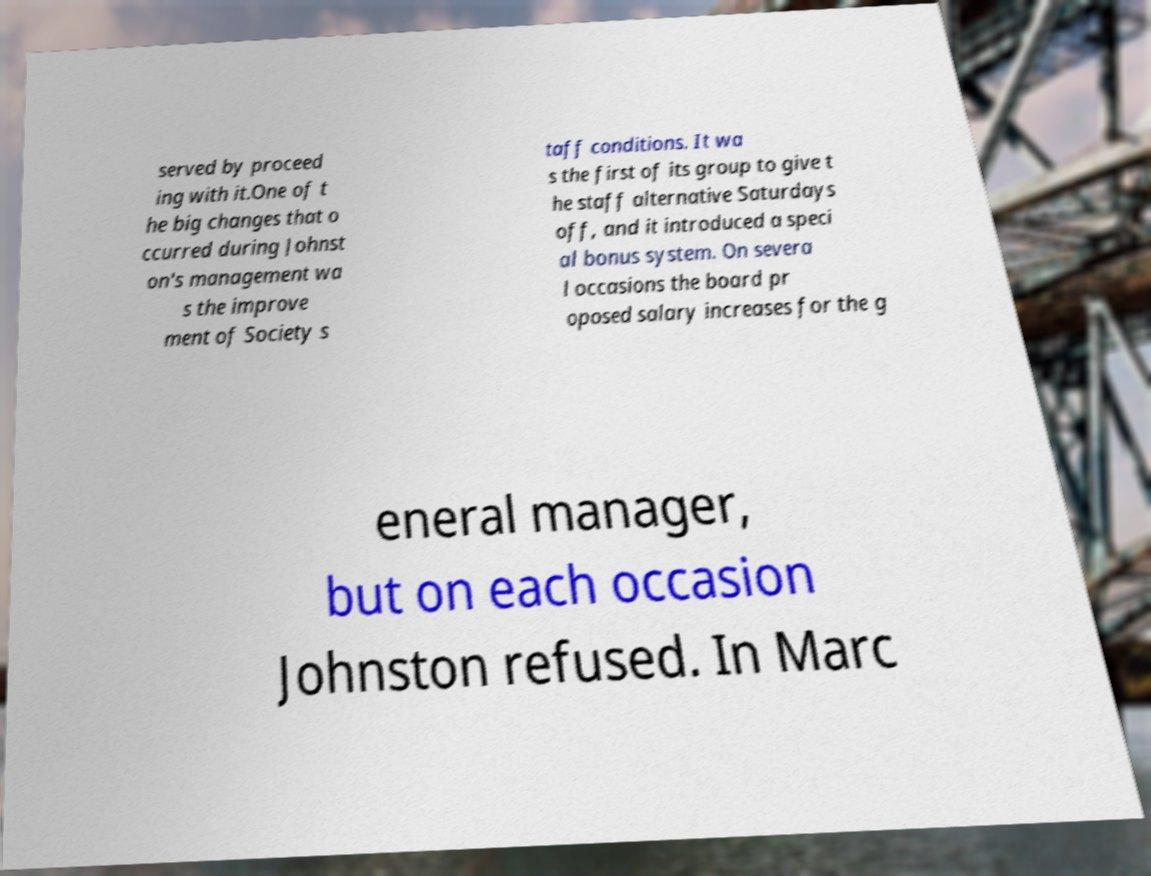Can you read and provide the text displayed in the image?This photo seems to have some interesting text. Can you extract and type it out for me? served by proceed ing with it.One of t he big changes that o ccurred during Johnst on's management wa s the improve ment of Society s taff conditions. It wa s the first of its group to give t he staff alternative Saturdays off, and it introduced a speci al bonus system. On severa l occasions the board pr oposed salary increases for the g eneral manager, but on each occasion Johnston refused. In Marc 